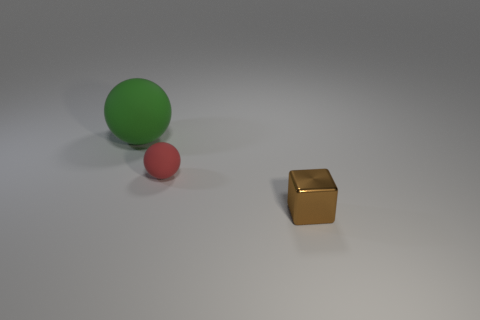The block is what color?
Keep it short and to the point. Brown. There is a object that is to the left of the small thing that is to the left of the shiny object in front of the big green matte thing; what shape is it?
Keep it short and to the point. Sphere. What is the thing that is to the left of the cube and in front of the large thing made of?
Your answer should be compact. Rubber. The small thing that is in front of the matte ball that is in front of the large rubber sphere is what shape?
Give a very brief answer. Cube. Are there any other things that are the same color as the big object?
Keep it short and to the point. No. There is a red object; does it have the same size as the object right of the small matte object?
Ensure brevity in your answer.  Yes. What number of small objects are either red matte objects or things?
Provide a succinct answer. 2. Is the number of tiny brown blocks greater than the number of cyan matte cubes?
Ensure brevity in your answer.  Yes. What number of red objects are in front of the matte sphere that is in front of the large green ball behind the red sphere?
Ensure brevity in your answer.  0. The tiny metal thing is what shape?
Your answer should be compact. Cube. 